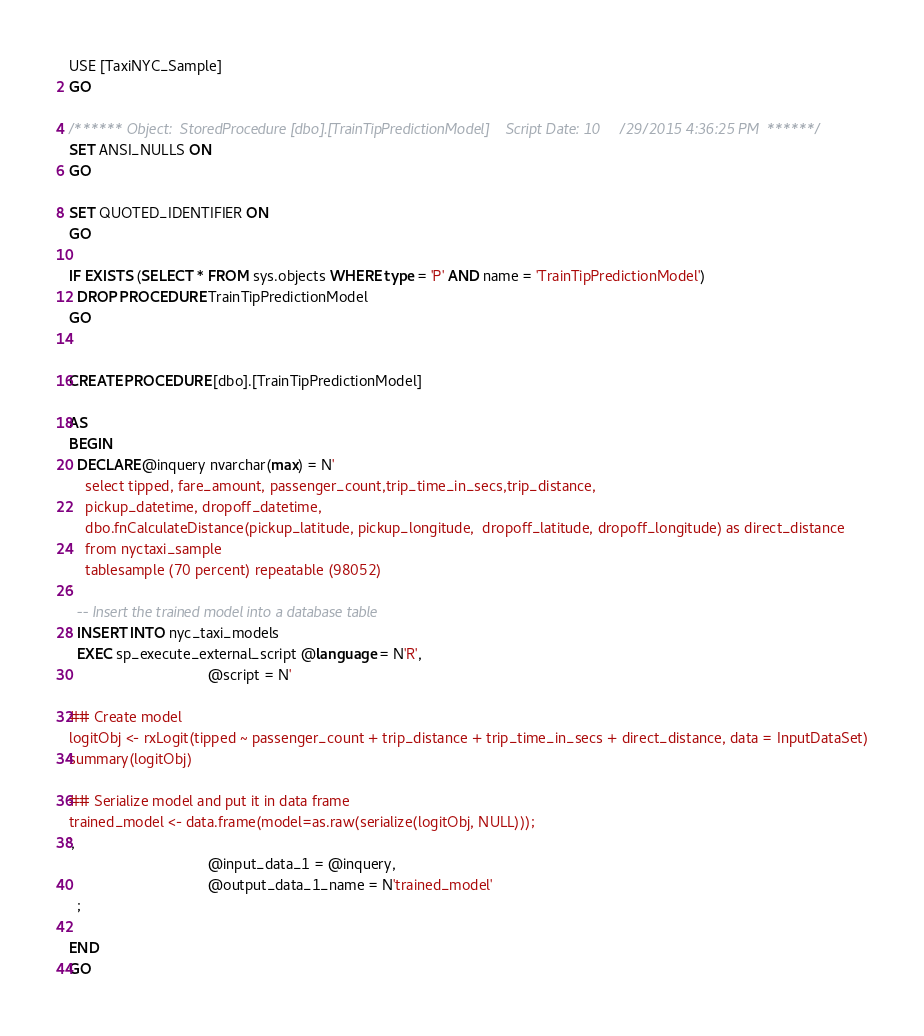Convert code to text. <code><loc_0><loc_0><loc_500><loc_500><_SQL_>USE [TaxiNYC_Sample]
GO

/****** Object:  StoredProcedure [dbo].[TrainTipPredictionModel]    Script Date: 10/29/2015 4:36:25 PM ******/
SET ANSI_NULLS ON
GO

SET QUOTED_IDENTIFIER ON
GO

IF EXISTS (SELECT * FROM sys.objects WHERE type = 'P' AND name = 'TrainTipPredictionModel')
  DROP PROCEDURE TrainTipPredictionModel
GO


CREATE PROCEDURE [dbo].[TrainTipPredictionModel]

AS
BEGIN
  DECLARE @inquery nvarchar(max) = N'
	select tipped, fare_amount, passenger_count,trip_time_in_secs,trip_distance, 
    pickup_datetime, dropoff_datetime, 
    dbo.fnCalculateDistance(pickup_latitude, pickup_longitude,  dropoff_latitude, dropoff_longitude) as direct_distance
    from nyctaxi_sample
    tablesample (70 percent) repeatable (98052)
'
  -- Insert the trained model into a database table
  INSERT INTO nyc_taxi_models
  EXEC sp_execute_external_script @language = N'R',
                                  @script = N'

## Create model
logitObj <- rxLogit(tipped ~ passenger_count + trip_distance + trip_time_in_secs + direct_distance, data = InputDataSet)
summary(logitObj)

## Serialize model and put it in data frame
trained_model <- data.frame(model=as.raw(serialize(logitObj, NULL)));
',
                                  @input_data_1 = @inquery,
                                  @output_data_1_name = N'trained_model'
  ;

END
GO

</code> 